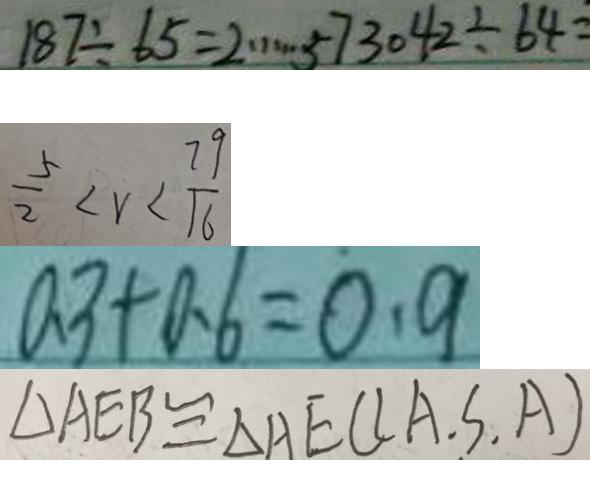<formula> <loc_0><loc_0><loc_500><loc_500>1 8 7 \div 6 5 = 2 \cdots 5 7 3 0 4 2 \div 6 4 = 
 \frac { 5 } { 2 } < v < \frac { 7 9 } { 1 6 } 
 a 3 + 0 . 6 = 0 . 9 
 \Delta A E B \cong \Delta A E C ( A . S . A )</formula> 